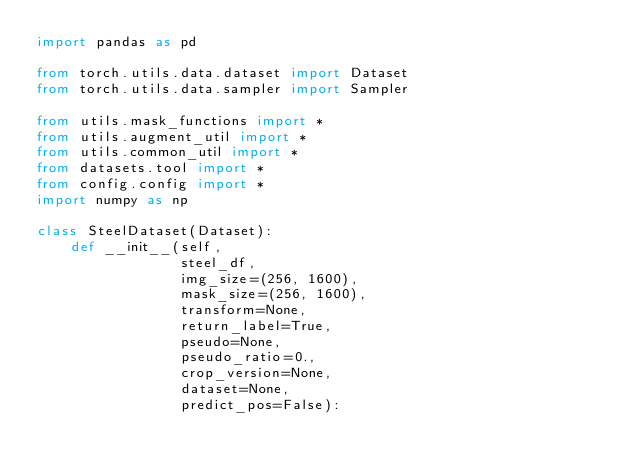Convert code to text. <code><loc_0><loc_0><loc_500><loc_500><_Python_>import pandas as pd

from torch.utils.data.dataset import Dataset
from torch.utils.data.sampler import Sampler

from utils.mask_functions import *
from utils.augment_util import *
from utils.common_util import *
from datasets.tool import *
from config.config import *
import numpy as np

class SteelDataset(Dataset):
    def __init__(self, 
                 steel_df,
                 img_size=(256, 1600),
                 mask_size=(256, 1600),
                 transform=None,
                 return_label=True,
                 pseudo=None,
                 pseudo_ratio=0.,
                 crop_version=None,
                 dataset=None,
                 predict_pos=False):</code> 